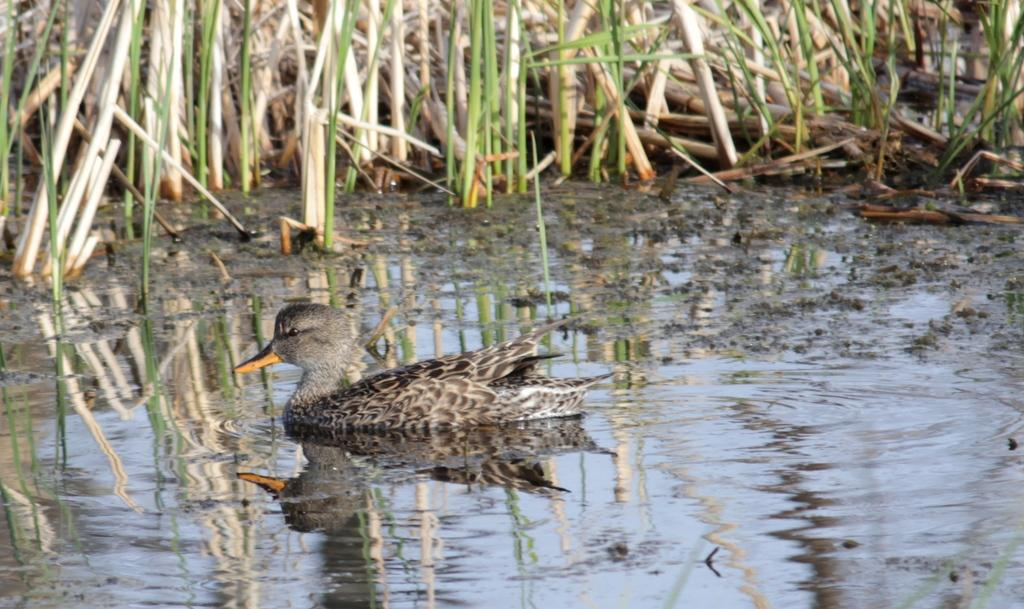What is the main subject of the image? There is a duck in the center of the image. Where is the duck located? The duck is on the water. What can be seen in the background of the image? There is grass visible in the background of the image. What type of property does the judge own in the image? There is no judge or property present in the image; it features a duck on the water with grass in the background. 